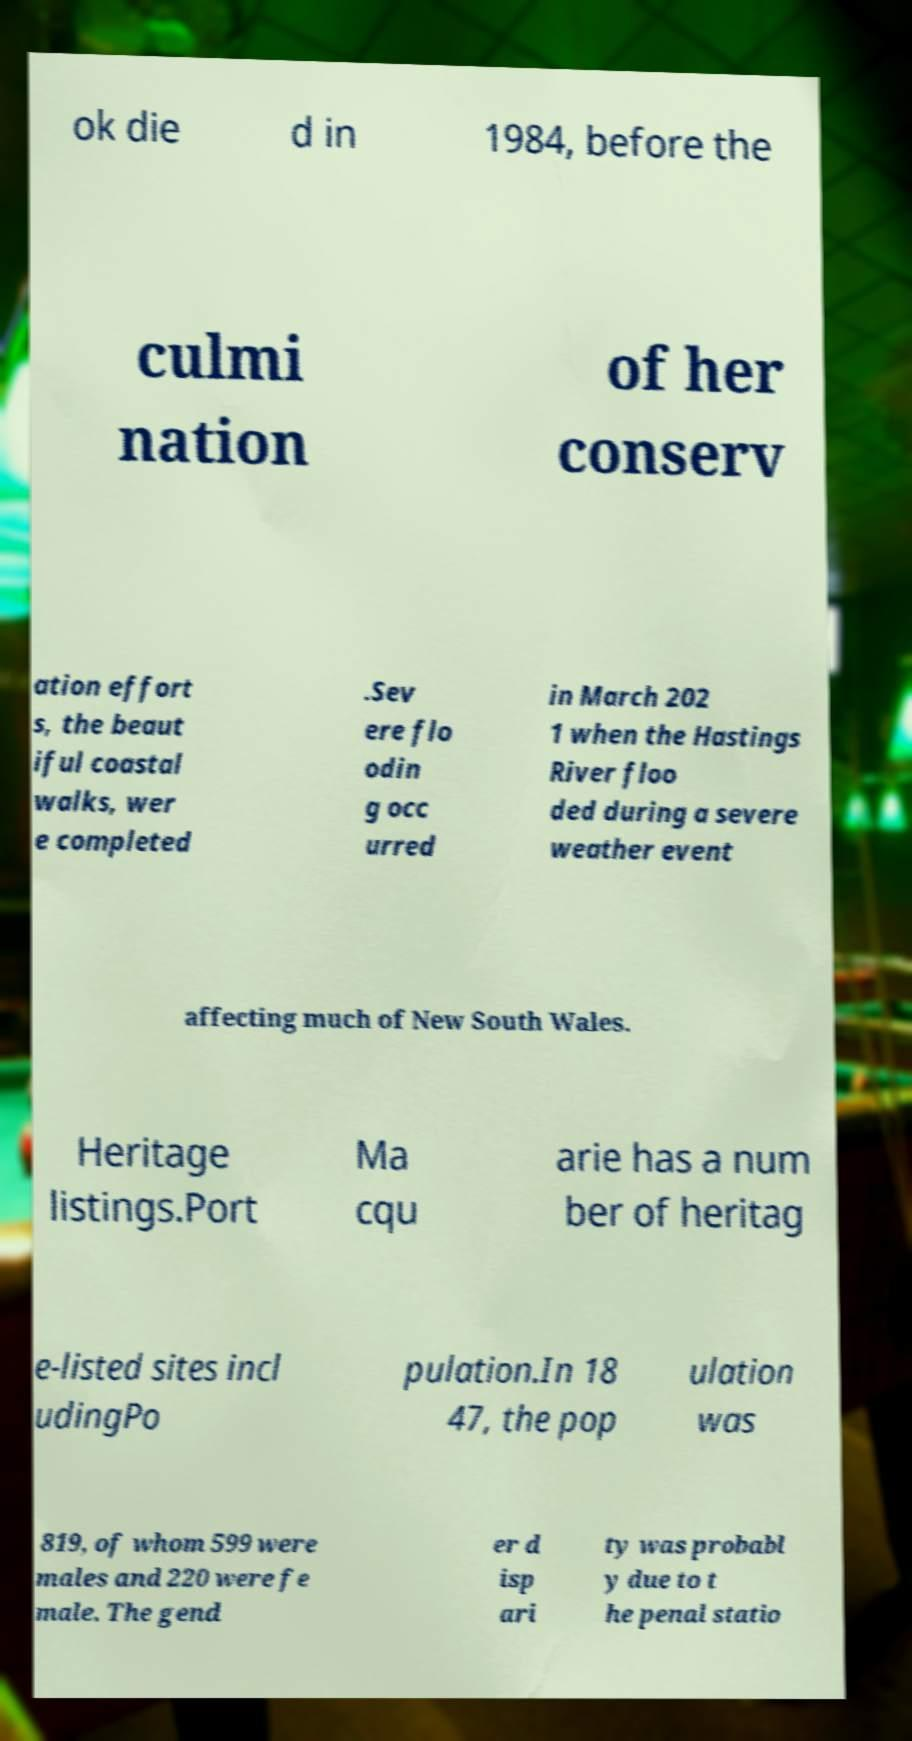Could you extract and type out the text from this image? ok die d in 1984, before the culmi nation of her conserv ation effort s, the beaut iful coastal walks, wer e completed .Sev ere flo odin g occ urred in March 202 1 when the Hastings River floo ded during a severe weather event affecting much of New South Wales. Heritage listings.Port Ma cqu arie has a num ber of heritag e-listed sites incl udingPo pulation.In 18 47, the pop ulation was 819, of whom 599 were males and 220 were fe male. The gend er d isp ari ty was probabl y due to t he penal statio 